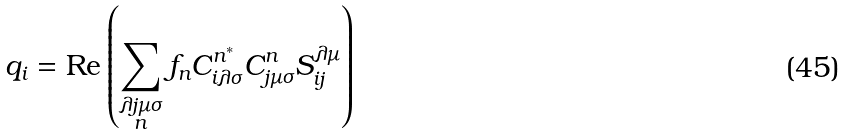Convert formula to latex. <formula><loc_0><loc_0><loc_500><loc_500>q _ { i } = \text {Re} \left ( \sum _ { \substack { \lambda j \mu \sigma \\ n } } f _ { n } C _ { i \lambda \sigma } ^ { n ^ { * } } C _ { j \mu \sigma } ^ { n } S _ { i j } ^ { \lambda \mu } \right )</formula> 